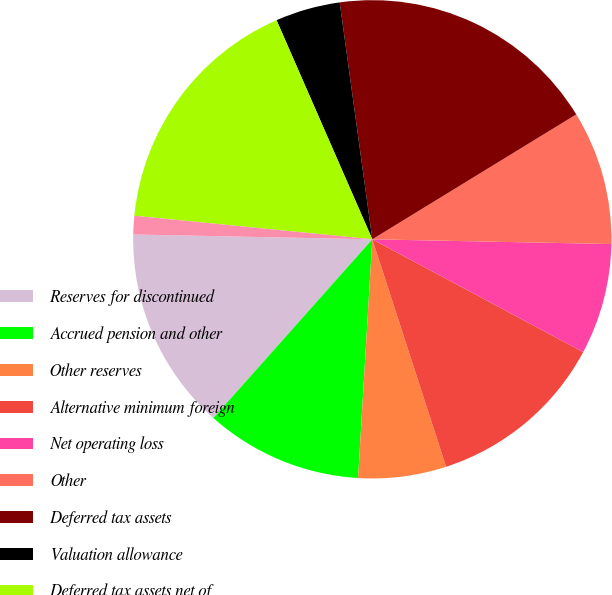Convert chart. <chart><loc_0><loc_0><loc_500><loc_500><pie_chart><fcel>Reserves for discontinued<fcel>Accrued pension and other<fcel>Other reserves<fcel>Alternative minimum foreign<fcel>Net operating loss<fcel>Other<fcel>Deferred tax assets<fcel>Valuation allowance<fcel>Deferred tax assets net of<fcel>Property plant and equipment<nl><fcel>13.75%<fcel>10.62%<fcel>5.94%<fcel>12.19%<fcel>7.5%<fcel>9.06%<fcel>18.43%<fcel>4.38%<fcel>16.87%<fcel>1.25%<nl></chart> 